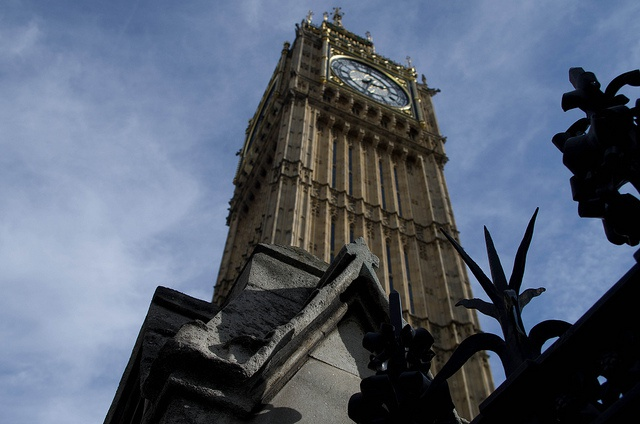Describe the objects in this image and their specific colors. I can see a clock in gray, darkgray, black, and blue tones in this image. 